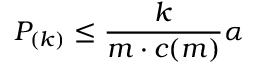Convert formula to latex. <formula><loc_0><loc_0><loc_500><loc_500>P _ { ( k ) } \leq { \frac { k } { m \cdot c ( m ) } } \alpha</formula> 